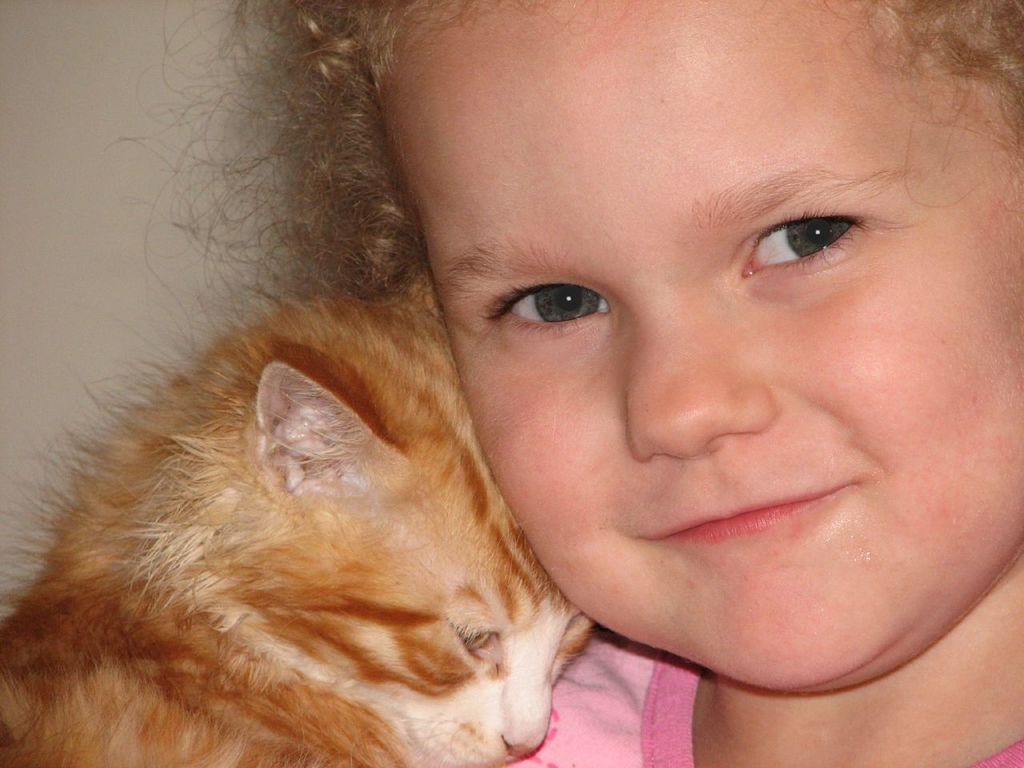What is the main subject located on the right side of the image? There is a girl in the image, positioned towards the right. What is the other main subject located in the image? There is a cat in the image, positioned towards the bottom. What type of structure can be seen on the left side of the image? There is a wall in the image, positioned towards the left. How many oranges are being held by the girl in the image? There are no oranges present in the image. What does the girl need to do in order to brush her tooth in the image? There is no toothbrush or tooth mentioned in the image, so it is not possible to determine what the girl might need to do to brush her tooth. 